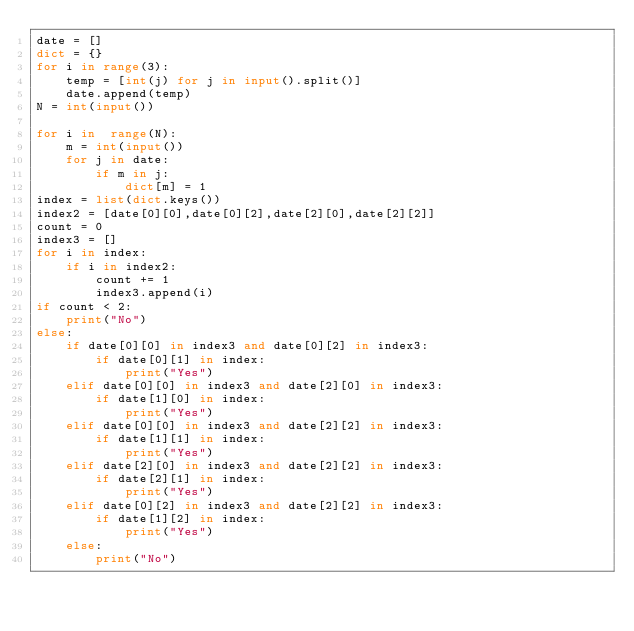<code> <loc_0><loc_0><loc_500><loc_500><_Python_>date = []
dict = {}
for i in range(3):
    temp = [int(j) for j in input().split()]
    date.append(temp)
N = int(input())

for i in  range(N):
    m = int(input())
    for j in date:
        if m in j:
            dict[m] = 1
index = list(dict.keys())
index2 = [date[0][0],date[0][2],date[2][0],date[2][2]]
count = 0
index3 = []
for i in index:
    if i in index2:
        count += 1
        index3.append(i)
if count < 2:
    print("No")
else:
    if date[0][0] in index3 and date[0][2] in index3:
        if date[0][1] in index:
            print("Yes")
    elif date[0][0] in index3 and date[2][0] in index3:
        if date[1][0] in index:
            print("Yes")
    elif date[0][0] in index3 and date[2][2] in index3:
        if date[1][1] in index:
            print("Yes")
    elif date[2][0] in index3 and date[2][2] in index3:
        if date[2][1] in index:
            print("Yes")
    elif date[0][2] in index3 and date[2][2] in index3:
        if date[1][2] in index:
            print("Yes")
    else:
        print("No")</code> 